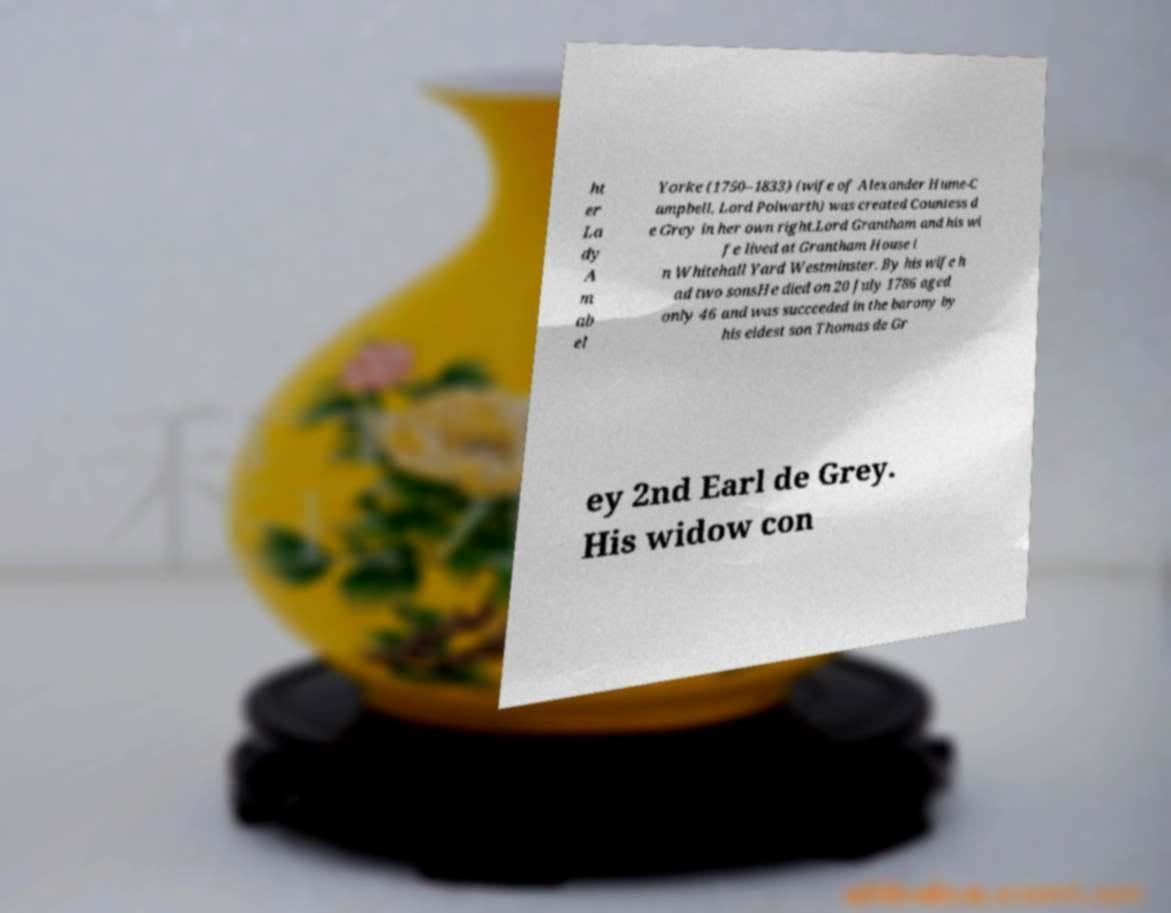Please identify and transcribe the text found in this image. ht er La dy A m ab el Yorke (1750–1833) (wife of Alexander Hume-C ampbell, Lord Polwarth) was created Countess d e Grey in her own right.Lord Grantham and his wi fe lived at Grantham House i n Whitehall Yard Westminster. By his wife h ad two sonsHe died on 20 July 1786 aged only 46 and was succeeded in the barony by his eldest son Thomas de Gr ey 2nd Earl de Grey. His widow con 